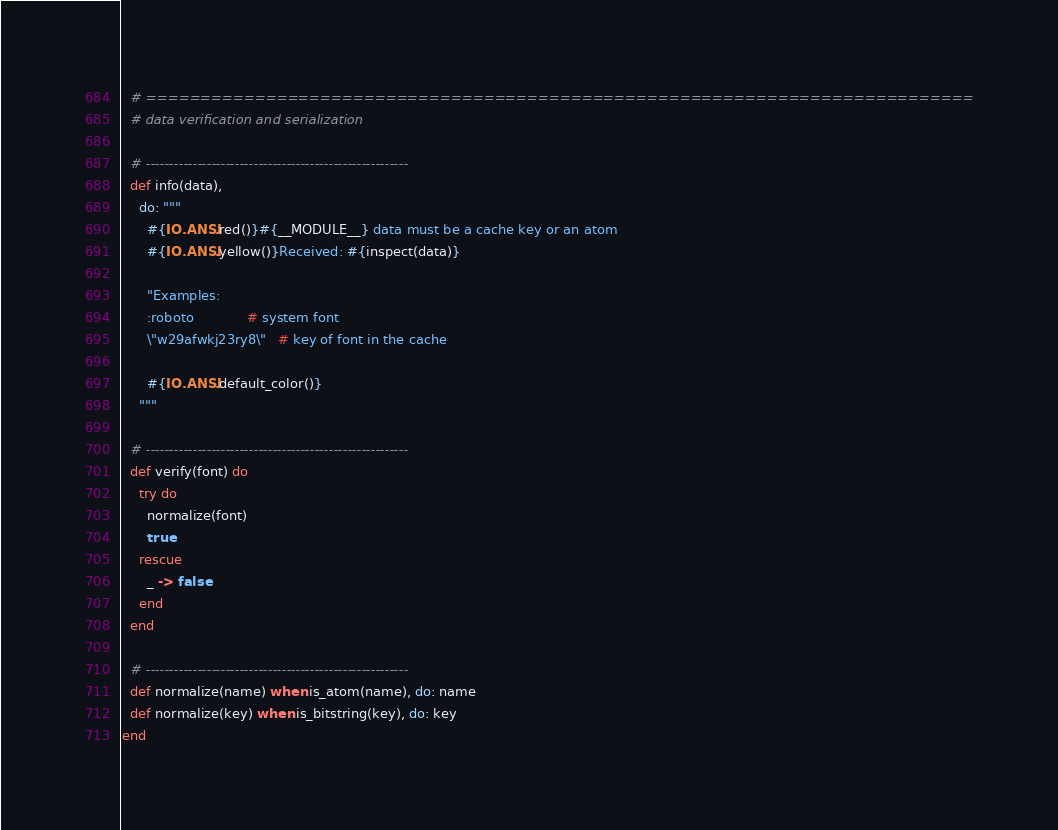<code> <loc_0><loc_0><loc_500><loc_500><_Elixir_>
  # ============================================================================
  # data verification and serialization

  # --------------------------------------------------------
  def info(data),
    do: """
      #{IO.ANSI.red()}#{__MODULE__} data must be a cache key or an atom
      #{IO.ANSI.yellow()}Received: #{inspect(data)}

      "Examples:
      :roboto             # system font
      \"w29afwkj23ry8\"   # key of font in the cache

      #{IO.ANSI.default_color()}
    """

  # --------------------------------------------------------
  def verify(font) do
    try do
      normalize(font)
      true
    rescue
      _ -> false
    end
  end

  # --------------------------------------------------------
  def normalize(name) when is_atom(name), do: name
  def normalize(key) when is_bitstring(key), do: key
end
</code> 